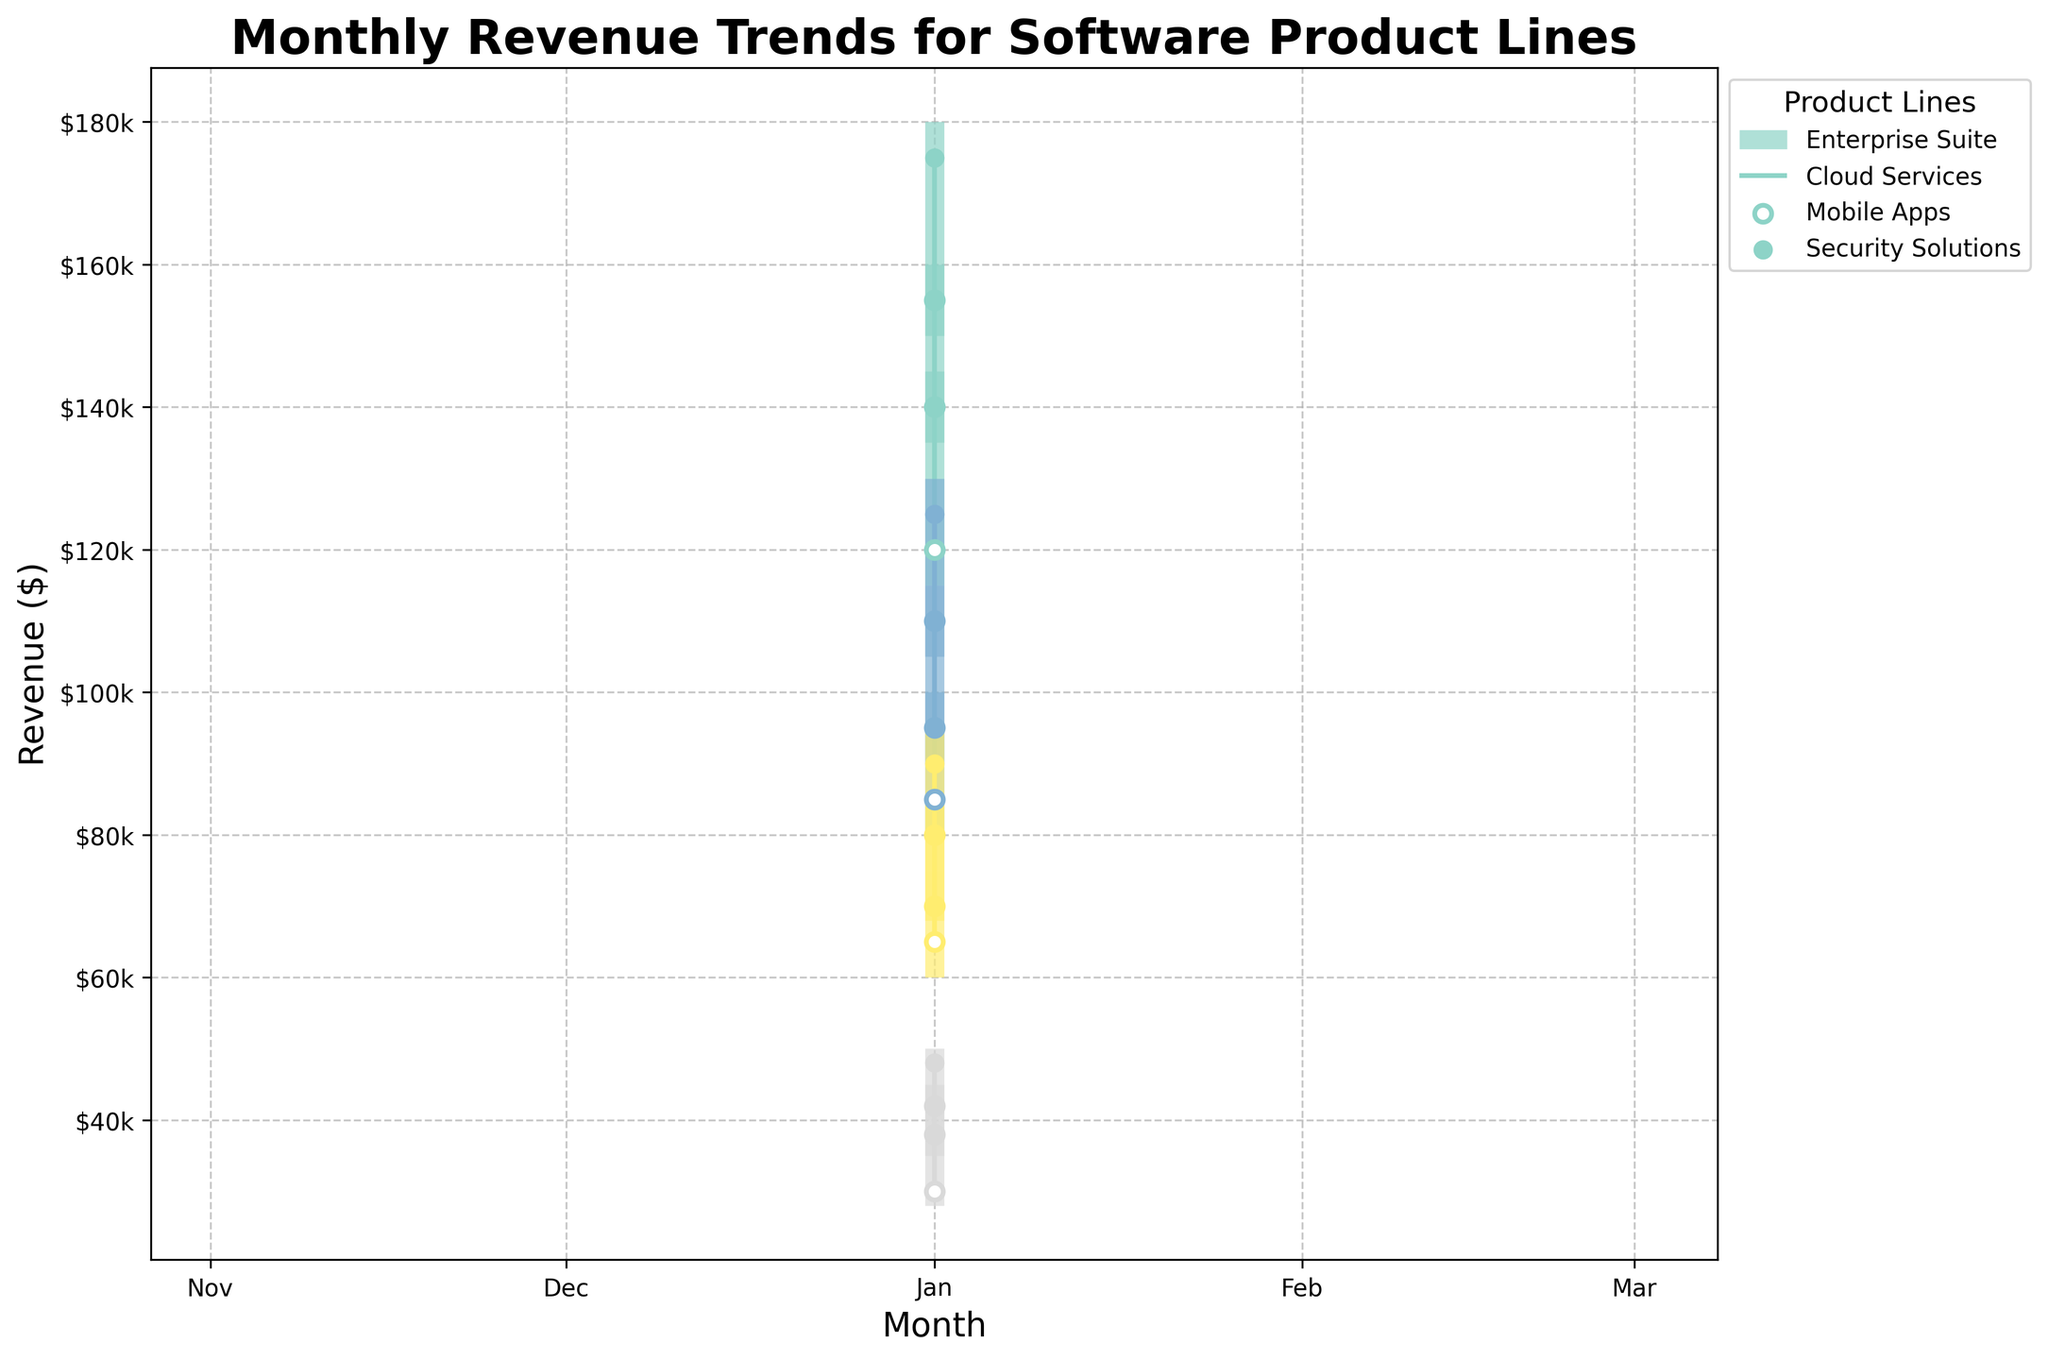What is the title of the plot? The title is provided at the top of the plot. By looking at the uppermost part of the plot, we can read the title.
Answer: Monthly Revenue Trends for Software Product Lines How many different product lines are being compared in the figure? By identifying the different colors and checking the legend at the side of the plot, we can count the number of product lines.
Answer: 4 Which product line experienced the highest peak revenue in March? We need to look at the highest point (High) indicated in March for each product line and compare these values.
Answer: Enterprise Suite What was the lowest revenue for Cloud Services in January? By locating the Cloud Services line in January, we can see the lowest point (Low) on the graph.
Answer: $80,000 Which product line had the most significant increase in revenue from the opening figure to the closing figure in February? We need to calculate the difference between the opening (Open) and closing (Close) figures for each product line in February and compare these differences.
Answer: Enterprise Suite In which month did the Security Solutions product line see the biggest difference between its peak and trough revenues? For Security Solutions, we need to find the month where the difference between the high (High) and low (Low) values is the largest.
Answer: March Comparing all three months, which product line showed a consistent increase in their closing revenues each month? We need to look at the closing figures (Close) for each month within each product line and determine which product shows increasing values month over month.
Answer: Mobile Apps Which product line had the smallest revenue range (High - Low) in March? To find the smallest revenue range in March, calculate the difference between High and Low for each product line in that month and identify the smallest value.
Answer: Mobile Apps Which product line had the highest average closing revenue over the three months? Calculate the average closing revenue for each product line by summing the closing revenues for January, February, and March, and then dividing by three. Compare the averages to determine which is the highest.
Answer: Enterprise Suite 